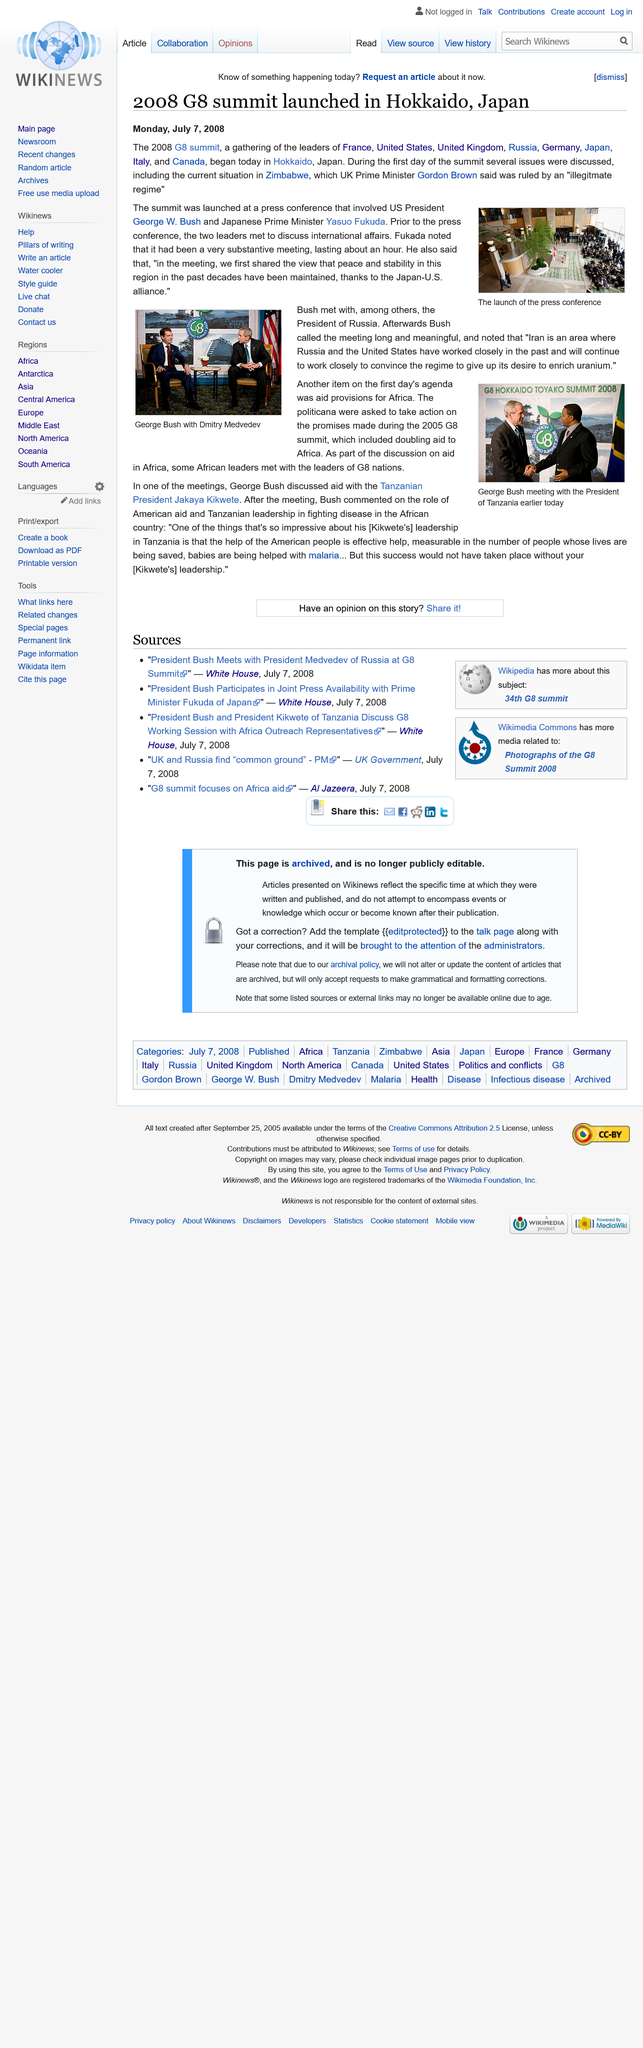Mention a couple of crucial points in this snapshot. The 2008 G8 summit was launched in Hokkaido, Japan. On Monday, July 7th, 2008, the article was published. At the 2008 G8 summit, the leaders of France, the United States, the United Kingdom, Russia, Germany, Japan, Italy, and Canada gathered to discuss important global issues. 